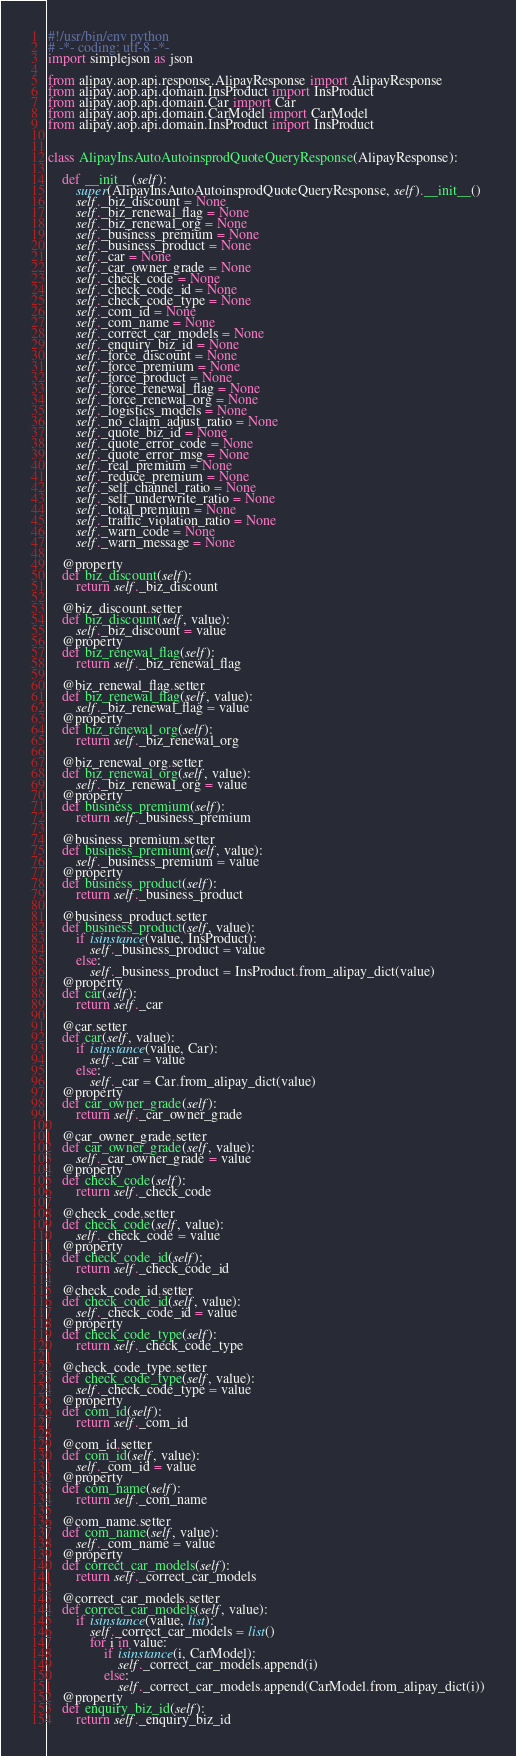Convert code to text. <code><loc_0><loc_0><loc_500><loc_500><_Python_>#!/usr/bin/env python
# -*- coding: utf-8 -*-
import simplejson as json

from alipay.aop.api.response.AlipayResponse import AlipayResponse
from alipay.aop.api.domain.InsProduct import InsProduct
from alipay.aop.api.domain.Car import Car
from alipay.aop.api.domain.CarModel import CarModel
from alipay.aop.api.domain.InsProduct import InsProduct


class AlipayInsAutoAutoinsprodQuoteQueryResponse(AlipayResponse):

    def __init__(self):
        super(AlipayInsAutoAutoinsprodQuoteQueryResponse, self).__init__()
        self._biz_discount = None
        self._biz_renewal_flag = None
        self._biz_renewal_org = None
        self._business_premium = None
        self._business_product = None
        self._car = None
        self._car_owner_grade = None
        self._check_code = None
        self._check_code_id = None
        self._check_code_type = None
        self._com_id = None
        self._com_name = None
        self._correct_car_models = None
        self._enquiry_biz_id = None
        self._force_discount = None
        self._force_premium = None
        self._force_product = None
        self._force_renewal_flag = None
        self._force_renewal_org = None
        self._logistics_models = None
        self._no_claim_adjust_ratio = None
        self._quote_biz_id = None
        self._quote_error_code = None
        self._quote_error_msg = None
        self._real_premium = None
        self._reduce_premium = None
        self._self_channel_ratio = None
        self._self_underwrite_ratio = None
        self._total_premium = None
        self._traffic_violation_ratio = None
        self._warn_code = None
        self._warn_message = None

    @property
    def biz_discount(self):
        return self._biz_discount

    @biz_discount.setter
    def biz_discount(self, value):
        self._biz_discount = value
    @property
    def biz_renewal_flag(self):
        return self._biz_renewal_flag

    @biz_renewal_flag.setter
    def biz_renewal_flag(self, value):
        self._biz_renewal_flag = value
    @property
    def biz_renewal_org(self):
        return self._biz_renewal_org

    @biz_renewal_org.setter
    def biz_renewal_org(self, value):
        self._biz_renewal_org = value
    @property
    def business_premium(self):
        return self._business_premium

    @business_premium.setter
    def business_premium(self, value):
        self._business_premium = value
    @property
    def business_product(self):
        return self._business_product

    @business_product.setter
    def business_product(self, value):
        if isinstance(value, InsProduct):
            self._business_product = value
        else:
            self._business_product = InsProduct.from_alipay_dict(value)
    @property
    def car(self):
        return self._car

    @car.setter
    def car(self, value):
        if isinstance(value, Car):
            self._car = value
        else:
            self._car = Car.from_alipay_dict(value)
    @property
    def car_owner_grade(self):
        return self._car_owner_grade

    @car_owner_grade.setter
    def car_owner_grade(self, value):
        self._car_owner_grade = value
    @property
    def check_code(self):
        return self._check_code

    @check_code.setter
    def check_code(self, value):
        self._check_code = value
    @property
    def check_code_id(self):
        return self._check_code_id

    @check_code_id.setter
    def check_code_id(self, value):
        self._check_code_id = value
    @property
    def check_code_type(self):
        return self._check_code_type

    @check_code_type.setter
    def check_code_type(self, value):
        self._check_code_type = value
    @property
    def com_id(self):
        return self._com_id

    @com_id.setter
    def com_id(self, value):
        self._com_id = value
    @property
    def com_name(self):
        return self._com_name

    @com_name.setter
    def com_name(self, value):
        self._com_name = value
    @property
    def correct_car_models(self):
        return self._correct_car_models

    @correct_car_models.setter
    def correct_car_models(self, value):
        if isinstance(value, list):
            self._correct_car_models = list()
            for i in value:
                if isinstance(i, CarModel):
                    self._correct_car_models.append(i)
                else:
                    self._correct_car_models.append(CarModel.from_alipay_dict(i))
    @property
    def enquiry_biz_id(self):
        return self._enquiry_biz_id
</code> 